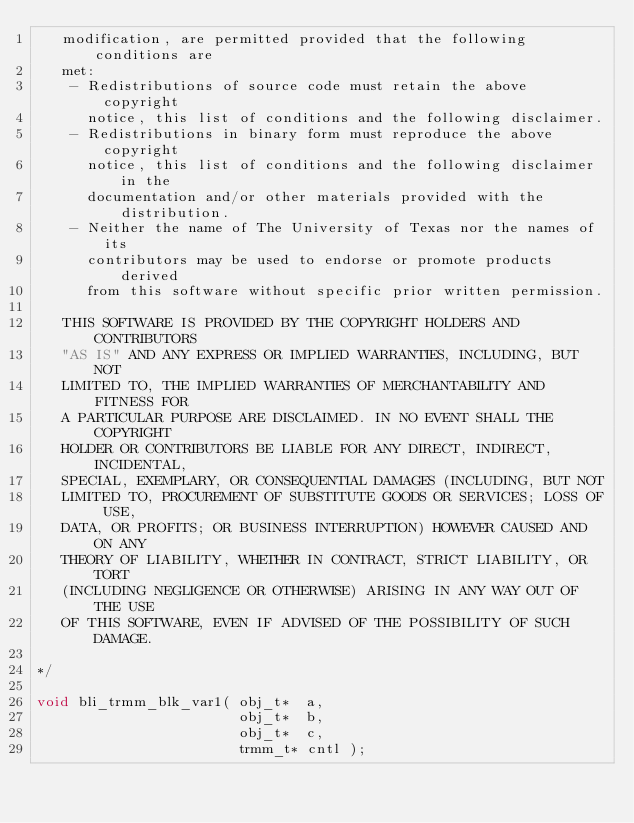Convert code to text. <code><loc_0><loc_0><loc_500><loc_500><_C_>   modification, are permitted provided that the following conditions are
   met:
    - Redistributions of source code must retain the above copyright
      notice, this list of conditions and the following disclaimer.
    - Redistributions in binary form must reproduce the above copyright
      notice, this list of conditions and the following disclaimer in the
      documentation and/or other materials provided with the distribution.
    - Neither the name of The University of Texas nor the names of its
      contributors may be used to endorse or promote products derived
      from this software without specific prior written permission.

   THIS SOFTWARE IS PROVIDED BY THE COPYRIGHT HOLDERS AND CONTRIBUTORS
   "AS IS" AND ANY EXPRESS OR IMPLIED WARRANTIES, INCLUDING, BUT NOT
   LIMITED TO, THE IMPLIED WARRANTIES OF MERCHANTABILITY AND FITNESS FOR
   A PARTICULAR PURPOSE ARE DISCLAIMED. IN NO EVENT SHALL THE COPYRIGHT
   HOLDER OR CONTRIBUTORS BE LIABLE FOR ANY DIRECT, INDIRECT, INCIDENTAL,
   SPECIAL, EXEMPLARY, OR CONSEQUENTIAL DAMAGES (INCLUDING, BUT NOT
   LIMITED TO, PROCUREMENT OF SUBSTITUTE GOODS OR SERVICES; LOSS OF USE,
   DATA, OR PROFITS; OR BUSINESS INTERRUPTION) HOWEVER CAUSED AND ON ANY
   THEORY OF LIABILITY, WHETHER IN CONTRACT, STRICT LIABILITY, OR TORT
   (INCLUDING NEGLIGENCE OR OTHERWISE) ARISING IN ANY WAY OUT OF THE USE
   OF THIS SOFTWARE, EVEN IF ADVISED OF THE POSSIBILITY OF SUCH DAMAGE.

*/

void bli_trmm_blk_var1( obj_t*  a,
                        obj_t*  b,
                        obj_t*  c,
                        trmm_t* cntl );

</code> 